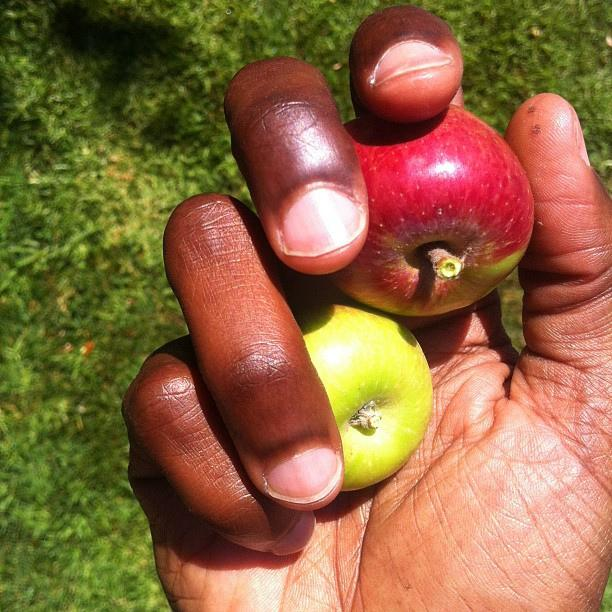What race is this person holding the apples? Please explain your reasoning. african. A person holding fruit has dark hands. africans have dark skin. 